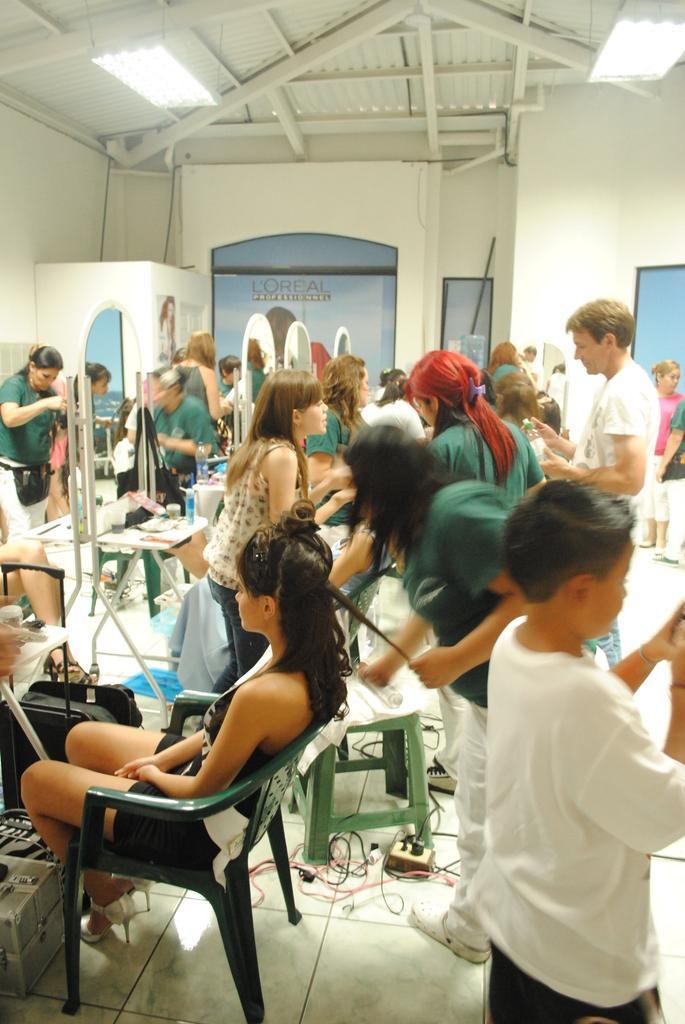Could you give a brief overview of what you see in this image? In the image there are group of people. In the image there is a woman sitting on chair and remaining people are standing. In background we can see a wall which is labelled as L'OREAL and it is in white color and on top there is a roof we can also see two lights from right to left. 